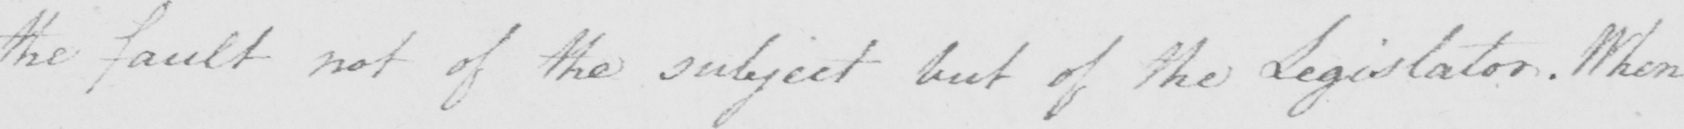Can you tell me what this handwritten text says? the fault not of the subject but of the Legislator . When 